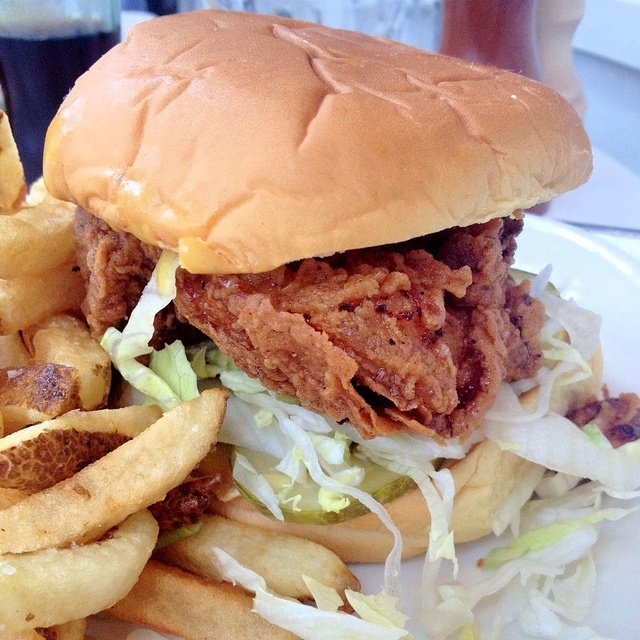Describe the objects in this image and their specific colors. I can see a sandwich in lightblue, tan, and brown tones in this image. 